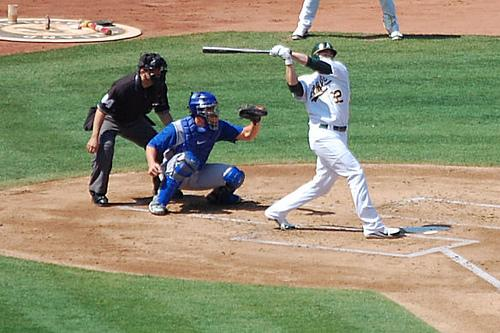What call will the umpire most likely make?

Choices:
A) foul
B) out
C) strike
D) ball strike 